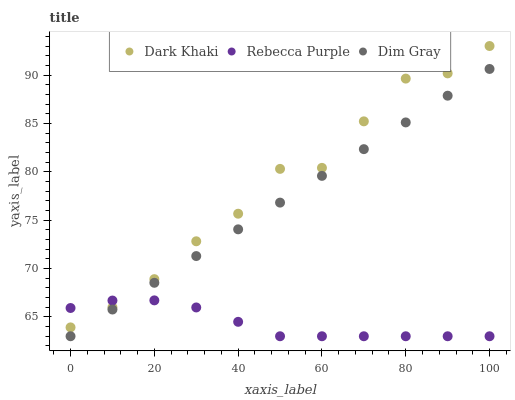Does Rebecca Purple have the minimum area under the curve?
Answer yes or no. Yes. Does Dark Khaki have the maximum area under the curve?
Answer yes or no. Yes. Does Dim Gray have the minimum area under the curve?
Answer yes or no. No. Does Dim Gray have the maximum area under the curve?
Answer yes or no. No. Is Dim Gray the smoothest?
Answer yes or no. Yes. Is Dark Khaki the roughest?
Answer yes or no. Yes. Is Rebecca Purple the smoothest?
Answer yes or no. No. Is Rebecca Purple the roughest?
Answer yes or no. No. Does Dim Gray have the lowest value?
Answer yes or no. Yes. Does Dark Khaki have the highest value?
Answer yes or no. Yes. Does Dim Gray have the highest value?
Answer yes or no. No. Is Dim Gray less than Dark Khaki?
Answer yes or no. Yes. Is Dark Khaki greater than Dim Gray?
Answer yes or no. Yes. Does Rebecca Purple intersect Dark Khaki?
Answer yes or no. Yes. Is Rebecca Purple less than Dark Khaki?
Answer yes or no. No. Is Rebecca Purple greater than Dark Khaki?
Answer yes or no. No. Does Dim Gray intersect Dark Khaki?
Answer yes or no. No. 